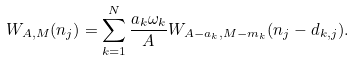Convert formula to latex. <formula><loc_0><loc_0><loc_500><loc_500>W _ { A , M } ( n _ { j } ) = \sum _ { k = 1 } ^ { N } \frac { a _ { k } \omega _ { k } } { A } W _ { A - a _ { k } , M - m _ { k } } ( n _ { j } - d _ { k , j } ) .</formula> 